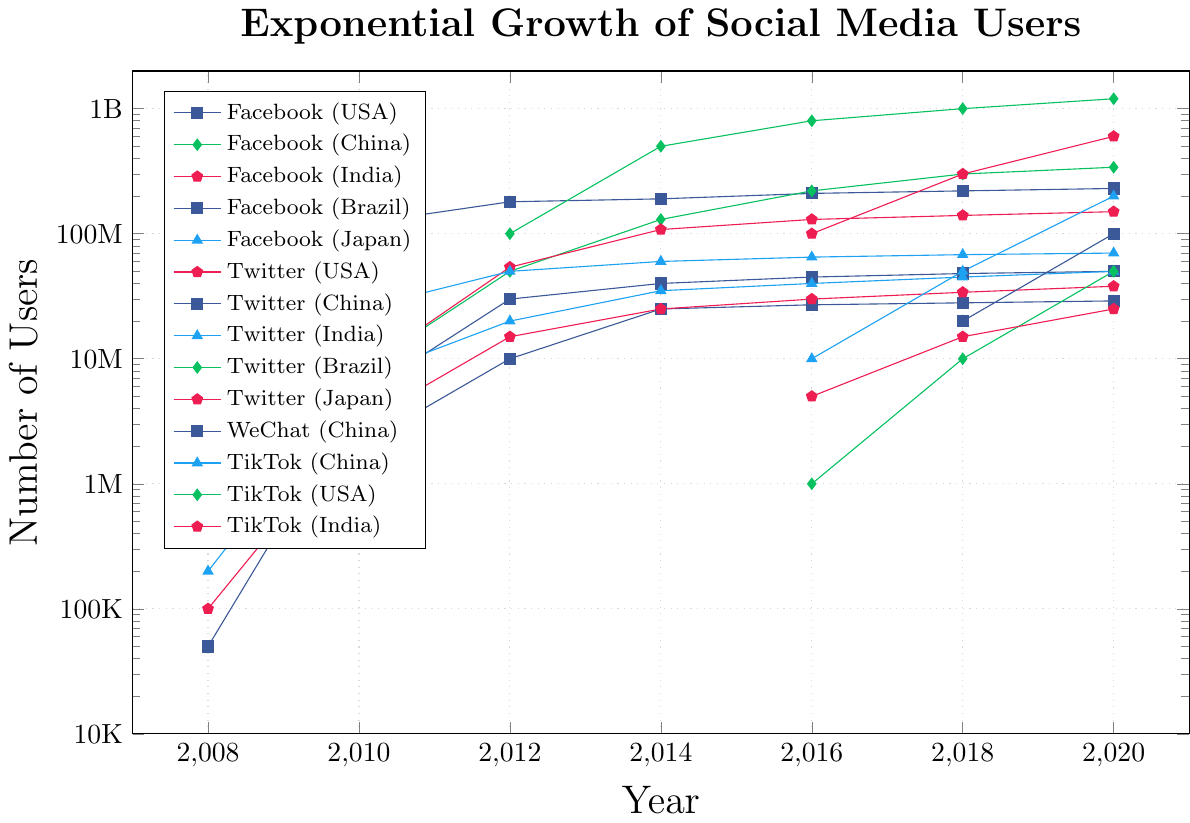1. Which country had the highest number of Facebook users in 2020? The plot shows multiple lines representing different countries on Facebook over the years. By checking the data points for 2020, India had the highest number of users on Facebook, reaching 340 million.
Answer: India 2. How does the user growth of TikTok in China compare to that in India between 2016 and 2020? From the figure, locate the data points for TikTok in China and India from 2016 to 2020. In 2016, China had 100 million users while India had 10 million. By 2020, China reached 600 million and India reached 200 million. China added 500 million users, whereas India added 190 million users during this period.
Answer: TikTok user growth in China was higher than in India (500 million vs 190 million) 3. During which year did Brazil's Twitter user base first surpass 10 million? Look at the line representing Brazil's Twitter users. The data shows that from 2008 to 2012, the number of users was increasing. In 2012, the user count exceeded 10 million.
Answer: 2012 4. Which platform showed the most consistent exponential growth in China? Examine each platform's trend line for China. Only WeChat and TikTok are present for China. WeChat shows a continuous and rapid exponential growth from 2012 to 2020.
Answer: WeChat 5. What is the difference in the number of Twitter users in the USA and Japan in 2020? Check the data points for Twitter users in the USA and Japan in 2020. For the USA, the number is 70 million, and for Japan, it is 50 million. Substract these values to find the difference: 70 million - 50 million.
Answer: 20 million 6. Between 2016 and 2020, which country showed the largest increase in Facebook users? Evaluate the difference in Facebook users from 2016 to 2020 for each country. USA (20M), India (120M), Brazil (20M), and Japan (2M). India shows the largest increase with 120 million new users.
Answer: India 7. Which platform's user base in Brazil reached 50 million first, Facebook, Twitter, or TikTok? Compare the lines for Facebook, Twitter, and TikTok in Brazil. Facebook reached 50 million users before 2014, Twitter reached right before 2016, and TikTok achieved this by 2020.
Answer: Facebook 8. How many more users did WeChat have in 2020 than in 2012? From the plot, in 2012, WeChat had 100 million users, and by 2020, it reached 1.2 billion users. Subtract the 2012 value from the 2020 value: 1.2 billion - 100 million.
Answer: 1.1 billion 9. By how much did the number of Facebook users in Japan grow from 2008 to 2020? From the chart, identify the number of Facebook users in Japan in 2008 (0.5 million) and in 2020 (29 million). Calculate the growth: 29 million - 0.5 million.
Answer: 28.5 million 10. Which year did India surpass the USA in the number of Facebook users? Examine the data trend lines for Facebook in India and the USA. India surpasses the USA between 2016 and 2018. From 2016 onward, India's user count is explicitly higher than the USA's in 2018.
Answer: 2018 